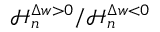<formula> <loc_0><loc_0><loc_500><loc_500>\mathcal { H } _ { n } ^ { \Delta w > 0 } / \mathcal { H } _ { n } ^ { \Delta w < 0 }</formula> 